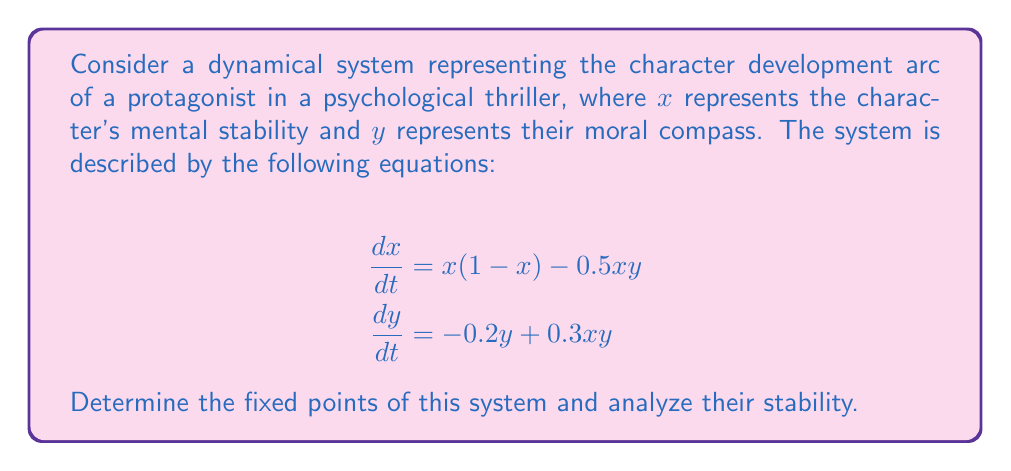Show me your answer to this math problem. 1. To find the fixed points, we set both equations equal to zero:

   $$x(1-x) - 0.5xy = 0$$
   $$-0.2y + 0.3xy = 0$$

2. From the second equation:
   $$y(-0.2 + 0.3x) = 0$$
   This gives us $y = 0$ or $x = \frac{2}{3}$

3. Substituting $y = 0$ into the first equation:
   $$x(1-x) = 0$$
   This gives us $x = 0$ or $x = 1$

4. When $x = \frac{2}{3}$, we substitute this into the first equation:
   $$\frac{2}{3}(1-\frac{2}{3}) - 0.5 \cdot \frac{2}{3}y = 0$$
   $$\frac{2}{9} - \frac{1}{3}y = 0$$
   $$y = \frac{2}{3}$$

5. Therefore, we have three fixed points: $(0,0)$, $(1,0)$, and $(\frac{2}{3},\frac{2}{3})$

6. To analyze stability, we need to find the Jacobian matrix:
   $$J = \begin{bmatrix}
   1-2x-0.5y & -0.5x \\
   0.3y & -0.2+0.3x
   \end{bmatrix}$$

7. Evaluate the Jacobian at each fixed point:

   At $(0,0)$: $J_{(0,0)} = \begin{bmatrix} 1 & 0 \\ 0 & -0.2 \end{bmatrix}$
   Eigenvalues: $\lambda_1 = 1$, $\lambda_2 = -0.2$
   This is an unstable saddle point.

   At $(1,0)$: $J_{(1,0)} = \begin{bmatrix} -1 & -0.5 \\ 0 & 0.1 \end{bmatrix}$
   Eigenvalues: $\lambda_1 = -1$, $\lambda_2 = 0.1$
   This is also an unstable saddle point.

   At $(\frac{2}{3},\frac{2}{3})$: $J_{(\frac{2}{3},\frac{2}{3})} = \begin{bmatrix} -\frac{1}{3} & -\frac{1}{3} \\ 0.2 & 0 \end{bmatrix}$
   Eigenvalues: $\lambda_{1,2} = -\frac{1}{6} \pm \frac{\sqrt{5}}{6}i$
   This is a stable spiral point.
Answer: Fixed points: $(0,0)$, $(1,0)$, $(\frac{2}{3},\frac{2}{3})$. $(0,0)$ and $(1,0)$ are unstable saddle points, $(\frac{2}{3},\frac{2}{3})$ is a stable spiral point. 